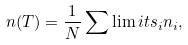Convert formula to latex. <formula><loc_0><loc_0><loc_500><loc_500>n ( T ) = \frac { 1 } { N } \sum \lim i t s _ { i } n _ { i } ,</formula> 